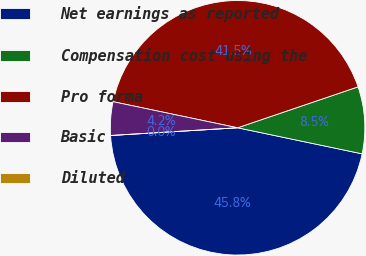Convert chart. <chart><loc_0><loc_0><loc_500><loc_500><pie_chart><fcel>Net earnings as reported<fcel>Compensation cost using the<fcel>Pro forma<fcel>Basic<fcel>Diluted<nl><fcel>45.75%<fcel>8.5%<fcel>41.5%<fcel>4.25%<fcel>0.0%<nl></chart> 